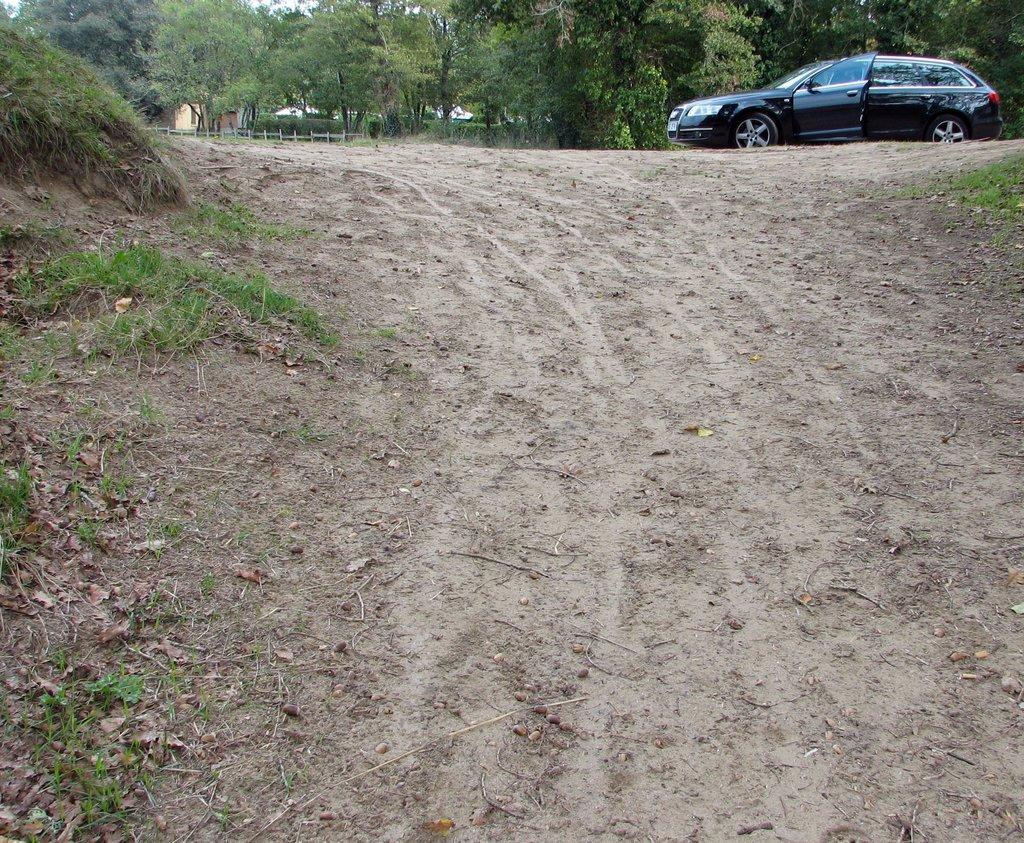Could you give a brief overview of what you see in this image? In this picture I can see there is some soil, there is grass on to left and there is a car parked here and there are trees in the backdrop and there is a building. 